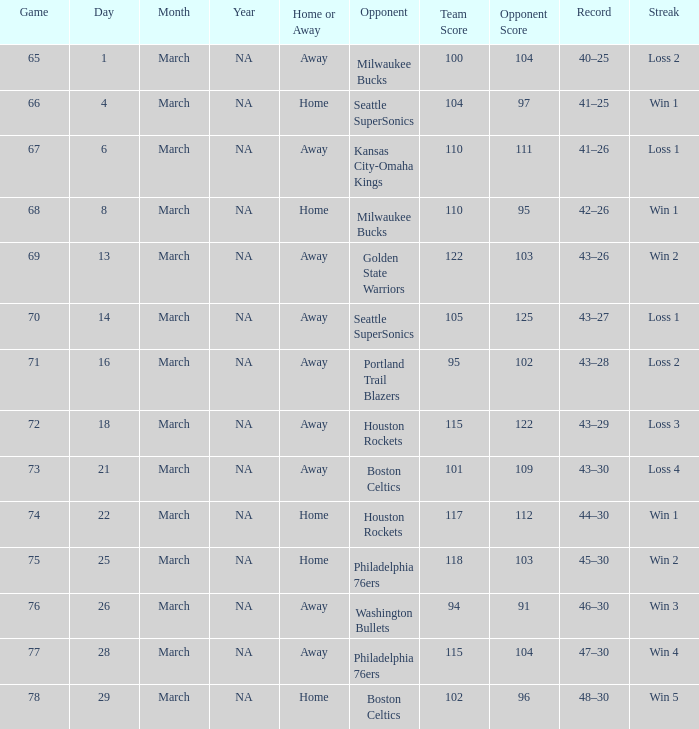What is Team, when Game is 73? @ Boston Celtics. 